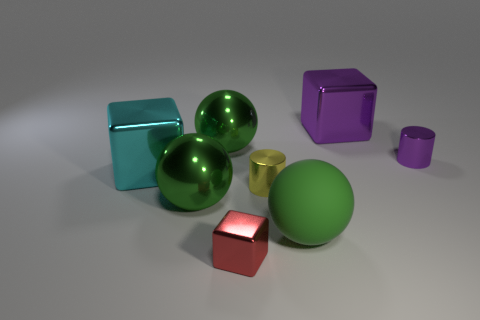There is a thing that is both in front of the purple shiny cube and to the right of the rubber object; what material is it made of?
Ensure brevity in your answer.  Metal. Are there any green things that are behind the cylinder that is behind the cyan thing?
Make the answer very short. Yes. What number of things are large gray metallic blocks or big green metal spheres?
Your answer should be compact. 2. There is a object that is both right of the tiny yellow metal thing and behind the tiny purple thing; what is its shape?
Provide a succinct answer. Cube. Does the big block behind the large cyan metallic object have the same material as the small yellow thing?
Provide a short and direct response. Yes. How many things are either large red metal objects or things that are to the right of the large purple thing?
Offer a very short reply. 1. What is the color of the other big block that is made of the same material as the purple cube?
Ensure brevity in your answer.  Cyan. How many small cylinders are the same material as the cyan block?
Give a very brief answer. 2. What number of cylinders are there?
Your response must be concise. 2. Is the color of the shiny cylinder on the left side of the small purple shiny cylinder the same as the large cube to the left of the big purple thing?
Your answer should be compact. No. 